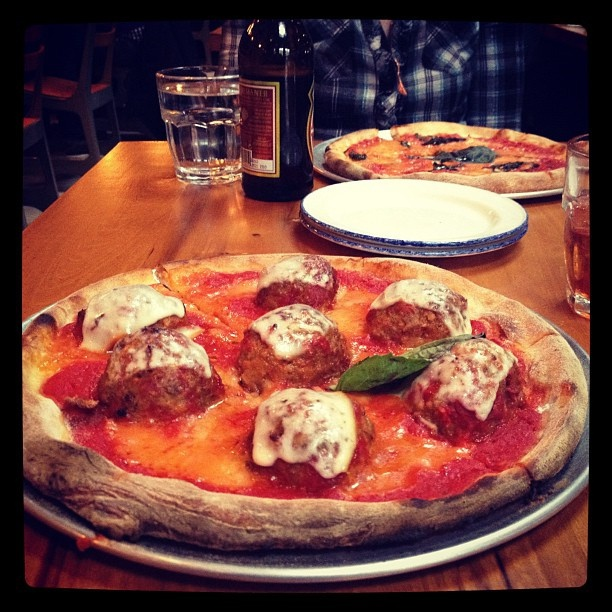Describe the objects in this image and their specific colors. I can see pizza in black, tan, and brown tones, dining table in black, red, brown, and salmon tones, people in black, navy, gray, and darkgray tones, bottle in black, maroon, brown, and lightpink tones, and pizza in black, tan, salmon, khaki, and brown tones in this image. 